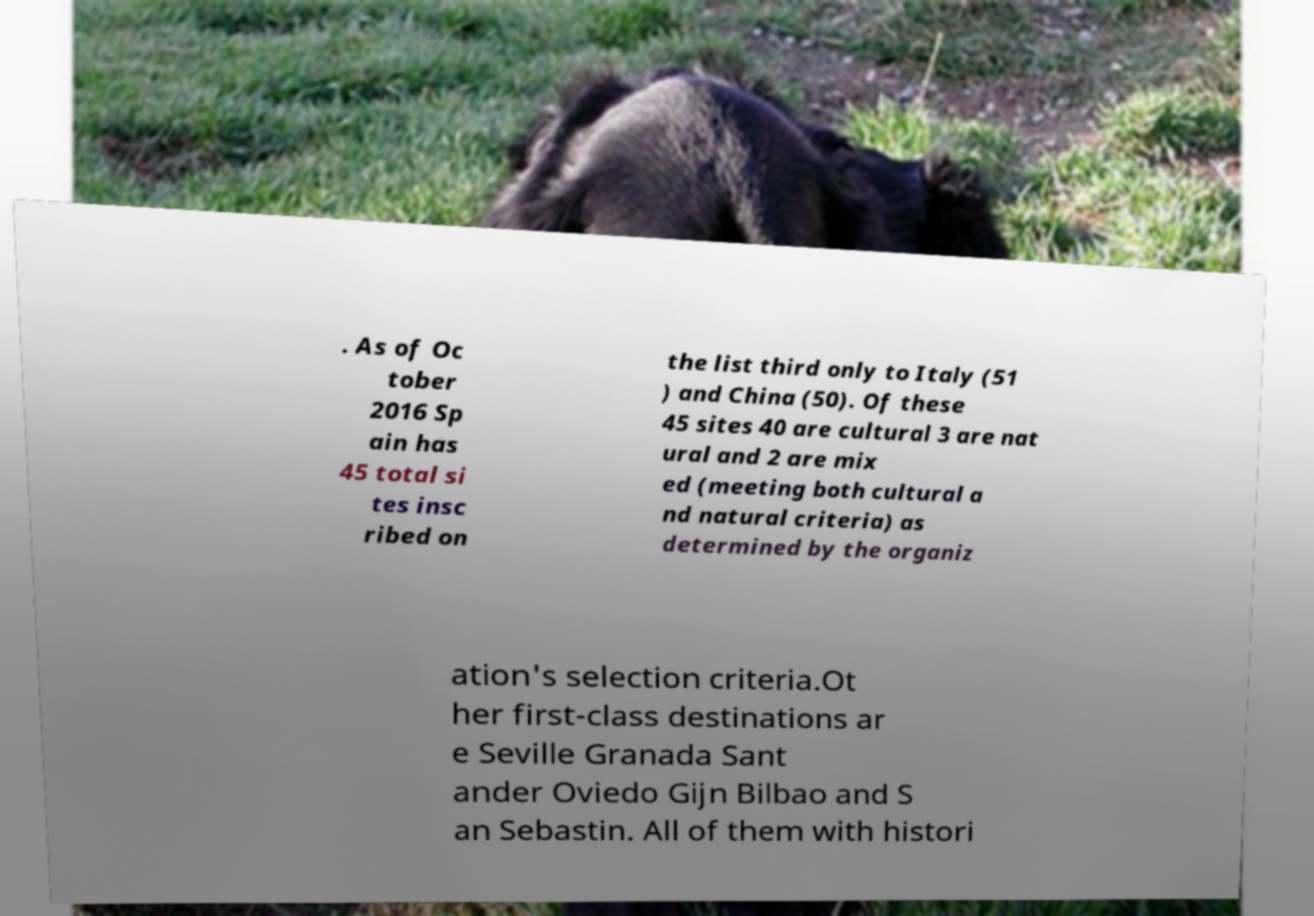I need the written content from this picture converted into text. Can you do that? . As of Oc tober 2016 Sp ain has 45 total si tes insc ribed on the list third only to Italy (51 ) and China (50). Of these 45 sites 40 are cultural 3 are nat ural and 2 are mix ed (meeting both cultural a nd natural criteria) as determined by the organiz ation's selection criteria.Ot her first-class destinations ar e Seville Granada Sant ander Oviedo Gijn Bilbao and S an Sebastin. All of them with histori 